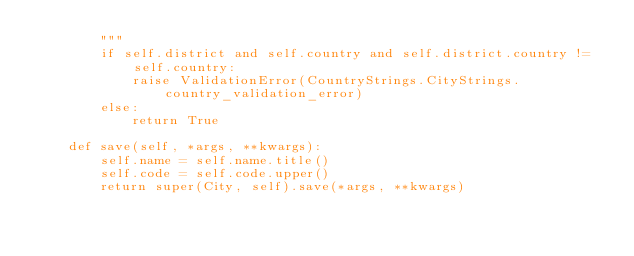Convert code to text. <code><loc_0><loc_0><loc_500><loc_500><_Python_>        """
        if self.district and self.country and self.district.country != self.country:
            raise ValidationError(CountryStrings.CityStrings.country_validation_error)
        else:
            return True

    def save(self, *args, **kwargs):
        self.name = self.name.title()
        self.code = self.code.upper()
        return super(City, self).save(*args, **kwargs)</code> 